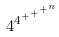Convert formula to latex. <formula><loc_0><loc_0><loc_500><loc_500>4 ^ { 4 ^ { + ^ { + ^ { + ^ { n } } } } }</formula> 